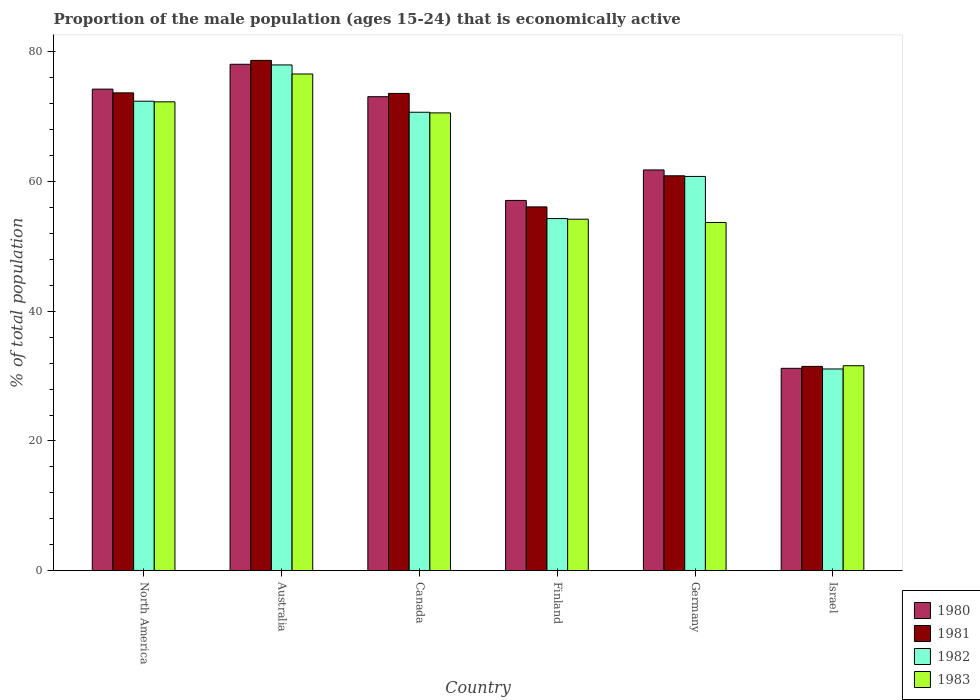How many different coloured bars are there?
Provide a short and direct response. 4. Are the number of bars per tick equal to the number of legend labels?
Make the answer very short. Yes. How many bars are there on the 5th tick from the right?
Your answer should be very brief. 4. What is the proportion of the male population that is economically active in 1980 in Germany?
Make the answer very short. 61.8. Across all countries, what is the maximum proportion of the male population that is economically active in 1983?
Provide a short and direct response. 76.6. Across all countries, what is the minimum proportion of the male population that is economically active in 1980?
Your response must be concise. 31.2. What is the total proportion of the male population that is economically active in 1980 in the graph?
Make the answer very short. 375.57. What is the difference between the proportion of the male population that is economically active in 1983 in Canada and that in North America?
Provide a short and direct response. -1.71. What is the difference between the proportion of the male population that is economically active in 1983 in Israel and the proportion of the male population that is economically active in 1981 in North America?
Your answer should be compact. -42.09. What is the average proportion of the male population that is economically active in 1980 per country?
Make the answer very short. 62.59. What is the difference between the proportion of the male population that is economically active of/in 1982 and proportion of the male population that is economically active of/in 1980 in North America?
Provide a succinct answer. -1.86. What is the ratio of the proportion of the male population that is economically active in 1983 in Canada to that in North America?
Make the answer very short. 0.98. Is the proportion of the male population that is economically active in 1983 in Finland less than that in Israel?
Provide a succinct answer. No. What is the difference between the highest and the second highest proportion of the male population that is economically active in 1983?
Provide a succinct answer. -4.29. What is the difference between the highest and the lowest proportion of the male population that is economically active in 1981?
Give a very brief answer. 47.2. In how many countries, is the proportion of the male population that is economically active in 1981 greater than the average proportion of the male population that is economically active in 1981 taken over all countries?
Your answer should be very brief. 3. Is it the case that in every country, the sum of the proportion of the male population that is economically active in 1982 and proportion of the male population that is economically active in 1981 is greater than the sum of proportion of the male population that is economically active in 1983 and proportion of the male population that is economically active in 1980?
Offer a terse response. No. What does the 1st bar from the left in Australia represents?
Keep it short and to the point. 1980. What does the 3rd bar from the right in Germany represents?
Provide a short and direct response. 1981. How many bars are there?
Make the answer very short. 24. Are all the bars in the graph horizontal?
Your answer should be very brief. No. Does the graph contain any zero values?
Your answer should be very brief. No. Where does the legend appear in the graph?
Give a very brief answer. Bottom right. How many legend labels are there?
Ensure brevity in your answer.  4. What is the title of the graph?
Provide a short and direct response. Proportion of the male population (ages 15-24) that is economically active. Does "1994" appear as one of the legend labels in the graph?
Provide a succinct answer. No. What is the label or title of the Y-axis?
Keep it short and to the point. % of total population. What is the % of total population of 1980 in North America?
Your response must be concise. 74.27. What is the % of total population of 1981 in North America?
Your answer should be compact. 73.69. What is the % of total population in 1982 in North America?
Your answer should be very brief. 72.41. What is the % of total population in 1983 in North America?
Keep it short and to the point. 72.31. What is the % of total population of 1980 in Australia?
Your answer should be very brief. 78.1. What is the % of total population of 1981 in Australia?
Ensure brevity in your answer.  78.7. What is the % of total population in 1982 in Australia?
Ensure brevity in your answer.  78. What is the % of total population of 1983 in Australia?
Your response must be concise. 76.6. What is the % of total population in 1980 in Canada?
Provide a short and direct response. 73.1. What is the % of total population of 1981 in Canada?
Offer a very short reply. 73.6. What is the % of total population in 1982 in Canada?
Offer a very short reply. 70.7. What is the % of total population in 1983 in Canada?
Your response must be concise. 70.6. What is the % of total population in 1980 in Finland?
Keep it short and to the point. 57.1. What is the % of total population in 1981 in Finland?
Make the answer very short. 56.1. What is the % of total population in 1982 in Finland?
Your answer should be very brief. 54.3. What is the % of total population in 1983 in Finland?
Make the answer very short. 54.2. What is the % of total population in 1980 in Germany?
Give a very brief answer. 61.8. What is the % of total population in 1981 in Germany?
Give a very brief answer. 60.9. What is the % of total population of 1982 in Germany?
Your answer should be very brief. 60.8. What is the % of total population in 1983 in Germany?
Give a very brief answer. 53.7. What is the % of total population in 1980 in Israel?
Offer a very short reply. 31.2. What is the % of total population of 1981 in Israel?
Your response must be concise. 31.5. What is the % of total population of 1982 in Israel?
Your response must be concise. 31.1. What is the % of total population in 1983 in Israel?
Give a very brief answer. 31.6. Across all countries, what is the maximum % of total population in 1980?
Your response must be concise. 78.1. Across all countries, what is the maximum % of total population of 1981?
Offer a terse response. 78.7. Across all countries, what is the maximum % of total population in 1983?
Give a very brief answer. 76.6. Across all countries, what is the minimum % of total population in 1980?
Give a very brief answer. 31.2. Across all countries, what is the minimum % of total population in 1981?
Your response must be concise. 31.5. Across all countries, what is the minimum % of total population of 1982?
Provide a short and direct response. 31.1. Across all countries, what is the minimum % of total population of 1983?
Ensure brevity in your answer.  31.6. What is the total % of total population of 1980 in the graph?
Your response must be concise. 375.57. What is the total % of total population of 1981 in the graph?
Your answer should be compact. 374.49. What is the total % of total population in 1982 in the graph?
Keep it short and to the point. 367.31. What is the total % of total population in 1983 in the graph?
Your response must be concise. 359.01. What is the difference between the % of total population in 1980 in North America and that in Australia?
Offer a very short reply. -3.83. What is the difference between the % of total population in 1981 in North America and that in Australia?
Your response must be concise. -5.01. What is the difference between the % of total population of 1982 in North America and that in Australia?
Offer a terse response. -5.59. What is the difference between the % of total population in 1983 in North America and that in Australia?
Make the answer very short. -4.29. What is the difference between the % of total population in 1980 in North America and that in Canada?
Give a very brief answer. 1.17. What is the difference between the % of total population in 1981 in North America and that in Canada?
Ensure brevity in your answer.  0.09. What is the difference between the % of total population of 1982 in North America and that in Canada?
Provide a succinct answer. 1.71. What is the difference between the % of total population of 1983 in North America and that in Canada?
Offer a very short reply. 1.71. What is the difference between the % of total population of 1980 in North America and that in Finland?
Ensure brevity in your answer.  17.17. What is the difference between the % of total population of 1981 in North America and that in Finland?
Your answer should be compact. 17.59. What is the difference between the % of total population in 1982 in North America and that in Finland?
Ensure brevity in your answer.  18.11. What is the difference between the % of total population in 1983 in North America and that in Finland?
Provide a short and direct response. 18.11. What is the difference between the % of total population of 1980 in North America and that in Germany?
Give a very brief answer. 12.47. What is the difference between the % of total population of 1981 in North America and that in Germany?
Offer a very short reply. 12.79. What is the difference between the % of total population in 1982 in North America and that in Germany?
Provide a succinct answer. 11.61. What is the difference between the % of total population of 1983 in North America and that in Germany?
Keep it short and to the point. 18.61. What is the difference between the % of total population in 1980 in North America and that in Israel?
Your answer should be compact. 43.07. What is the difference between the % of total population in 1981 in North America and that in Israel?
Your answer should be compact. 42.19. What is the difference between the % of total population in 1982 in North America and that in Israel?
Offer a terse response. 41.31. What is the difference between the % of total population of 1983 in North America and that in Israel?
Your answer should be very brief. 40.71. What is the difference between the % of total population in 1981 in Australia and that in Canada?
Keep it short and to the point. 5.1. What is the difference between the % of total population in 1982 in Australia and that in Canada?
Offer a very short reply. 7.3. What is the difference between the % of total population of 1981 in Australia and that in Finland?
Your answer should be very brief. 22.6. What is the difference between the % of total population of 1982 in Australia and that in Finland?
Give a very brief answer. 23.7. What is the difference between the % of total population in 1983 in Australia and that in Finland?
Keep it short and to the point. 22.4. What is the difference between the % of total population of 1980 in Australia and that in Germany?
Give a very brief answer. 16.3. What is the difference between the % of total population of 1982 in Australia and that in Germany?
Your answer should be compact. 17.2. What is the difference between the % of total population in 1983 in Australia and that in Germany?
Offer a very short reply. 22.9. What is the difference between the % of total population in 1980 in Australia and that in Israel?
Offer a terse response. 46.9. What is the difference between the % of total population in 1981 in Australia and that in Israel?
Offer a terse response. 47.2. What is the difference between the % of total population of 1982 in Australia and that in Israel?
Offer a terse response. 46.9. What is the difference between the % of total population in 1980 in Canada and that in Finland?
Offer a terse response. 16. What is the difference between the % of total population in 1982 in Canada and that in Finland?
Your answer should be compact. 16.4. What is the difference between the % of total population of 1980 in Canada and that in Germany?
Keep it short and to the point. 11.3. What is the difference between the % of total population in 1982 in Canada and that in Germany?
Offer a very short reply. 9.9. What is the difference between the % of total population in 1980 in Canada and that in Israel?
Make the answer very short. 41.9. What is the difference between the % of total population in 1981 in Canada and that in Israel?
Your answer should be compact. 42.1. What is the difference between the % of total population in 1982 in Canada and that in Israel?
Make the answer very short. 39.6. What is the difference between the % of total population in 1982 in Finland and that in Germany?
Offer a very short reply. -6.5. What is the difference between the % of total population in 1980 in Finland and that in Israel?
Keep it short and to the point. 25.9. What is the difference between the % of total population in 1981 in Finland and that in Israel?
Your response must be concise. 24.6. What is the difference between the % of total population in 1982 in Finland and that in Israel?
Your answer should be very brief. 23.2. What is the difference between the % of total population of 1983 in Finland and that in Israel?
Your response must be concise. 22.6. What is the difference between the % of total population in 1980 in Germany and that in Israel?
Provide a short and direct response. 30.6. What is the difference between the % of total population of 1981 in Germany and that in Israel?
Offer a terse response. 29.4. What is the difference between the % of total population in 1982 in Germany and that in Israel?
Provide a short and direct response. 29.7. What is the difference between the % of total population of 1983 in Germany and that in Israel?
Provide a succinct answer. 22.1. What is the difference between the % of total population of 1980 in North America and the % of total population of 1981 in Australia?
Your answer should be compact. -4.43. What is the difference between the % of total population of 1980 in North America and the % of total population of 1982 in Australia?
Your response must be concise. -3.73. What is the difference between the % of total population of 1980 in North America and the % of total population of 1983 in Australia?
Make the answer very short. -2.33. What is the difference between the % of total population of 1981 in North America and the % of total population of 1982 in Australia?
Make the answer very short. -4.31. What is the difference between the % of total population in 1981 in North America and the % of total population in 1983 in Australia?
Keep it short and to the point. -2.91. What is the difference between the % of total population in 1982 in North America and the % of total population in 1983 in Australia?
Provide a succinct answer. -4.19. What is the difference between the % of total population of 1980 in North America and the % of total population of 1981 in Canada?
Give a very brief answer. 0.67. What is the difference between the % of total population in 1980 in North America and the % of total population in 1982 in Canada?
Your response must be concise. 3.57. What is the difference between the % of total population of 1980 in North America and the % of total population of 1983 in Canada?
Your response must be concise. 3.67. What is the difference between the % of total population in 1981 in North America and the % of total population in 1982 in Canada?
Ensure brevity in your answer.  2.99. What is the difference between the % of total population of 1981 in North America and the % of total population of 1983 in Canada?
Your answer should be very brief. 3.09. What is the difference between the % of total population of 1982 in North America and the % of total population of 1983 in Canada?
Give a very brief answer. 1.81. What is the difference between the % of total population of 1980 in North America and the % of total population of 1981 in Finland?
Your answer should be very brief. 18.17. What is the difference between the % of total population in 1980 in North America and the % of total population in 1982 in Finland?
Your answer should be compact. 19.97. What is the difference between the % of total population in 1980 in North America and the % of total population in 1983 in Finland?
Make the answer very short. 20.07. What is the difference between the % of total population in 1981 in North America and the % of total population in 1982 in Finland?
Your response must be concise. 19.39. What is the difference between the % of total population in 1981 in North America and the % of total population in 1983 in Finland?
Provide a short and direct response. 19.49. What is the difference between the % of total population in 1982 in North America and the % of total population in 1983 in Finland?
Your answer should be compact. 18.21. What is the difference between the % of total population of 1980 in North America and the % of total population of 1981 in Germany?
Provide a short and direct response. 13.37. What is the difference between the % of total population of 1980 in North America and the % of total population of 1982 in Germany?
Your answer should be very brief. 13.47. What is the difference between the % of total population in 1980 in North America and the % of total population in 1983 in Germany?
Your response must be concise. 20.57. What is the difference between the % of total population of 1981 in North America and the % of total population of 1982 in Germany?
Your answer should be compact. 12.89. What is the difference between the % of total population in 1981 in North America and the % of total population in 1983 in Germany?
Make the answer very short. 19.99. What is the difference between the % of total population of 1982 in North America and the % of total population of 1983 in Germany?
Offer a terse response. 18.71. What is the difference between the % of total population of 1980 in North America and the % of total population of 1981 in Israel?
Your response must be concise. 42.77. What is the difference between the % of total population in 1980 in North America and the % of total population in 1982 in Israel?
Make the answer very short. 43.17. What is the difference between the % of total population in 1980 in North America and the % of total population in 1983 in Israel?
Your answer should be very brief. 42.67. What is the difference between the % of total population of 1981 in North America and the % of total population of 1982 in Israel?
Offer a terse response. 42.59. What is the difference between the % of total population of 1981 in North America and the % of total population of 1983 in Israel?
Offer a terse response. 42.09. What is the difference between the % of total population in 1982 in North America and the % of total population in 1983 in Israel?
Provide a succinct answer. 40.81. What is the difference between the % of total population of 1980 in Australia and the % of total population of 1982 in Canada?
Provide a succinct answer. 7.4. What is the difference between the % of total population in 1981 in Australia and the % of total population in 1982 in Canada?
Your response must be concise. 8. What is the difference between the % of total population of 1981 in Australia and the % of total population of 1983 in Canada?
Offer a very short reply. 8.1. What is the difference between the % of total population of 1980 in Australia and the % of total population of 1981 in Finland?
Make the answer very short. 22. What is the difference between the % of total population of 1980 in Australia and the % of total population of 1982 in Finland?
Your answer should be very brief. 23.8. What is the difference between the % of total population of 1980 in Australia and the % of total population of 1983 in Finland?
Keep it short and to the point. 23.9. What is the difference between the % of total population in 1981 in Australia and the % of total population in 1982 in Finland?
Your answer should be compact. 24.4. What is the difference between the % of total population in 1981 in Australia and the % of total population in 1983 in Finland?
Your response must be concise. 24.5. What is the difference between the % of total population in 1982 in Australia and the % of total population in 1983 in Finland?
Give a very brief answer. 23.8. What is the difference between the % of total population in 1980 in Australia and the % of total population in 1983 in Germany?
Offer a very short reply. 24.4. What is the difference between the % of total population of 1981 in Australia and the % of total population of 1982 in Germany?
Your answer should be very brief. 17.9. What is the difference between the % of total population of 1982 in Australia and the % of total population of 1983 in Germany?
Your answer should be very brief. 24.3. What is the difference between the % of total population of 1980 in Australia and the % of total population of 1981 in Israel?
Your answer should be very brief. 46.6. What is the difference between the % of total population in 1980 in Australia and the % of total population in 1983 in Israel?
Provide a succinct answer. 46.5. What is the difference between the % of total population in 1981 in Australia and the % of total population in 1982 in Israel?
Make the answer very short. 47.6. What is the difference between the % of total population of 1981 in Australia and the % of total population of 1983 in Israel?
Provide a short and direct response. 47.1. What is the difference between the % of total population of 1982 in Australia and the % of total population of 1983 in Israel?
Your answer should be compact. 46.4. What is the difference between the % of total population of 1980 in Canada and the % of total population of 1983 in Finland?
Provide a succinct answer. 18.9. What is the difference between the % of total population in 1981 in Canada and the % of total population in 1982 in Finland?
Keep it short and to the point. 19.3. What is the difference between the % of total population in 1981 in Canada and the % of total population in 1983 in Finland?
Ensure brevity in your answer.  19.4. What is the difference between the % of total population of 1980 in Canada and the % of total population of 1982 in Germany?
Provide a succinct answer. 12.3. What is the difference between the % of total population of 1981 in Canada and the % of total population of 1982 in Germany?
Offer a very short reply. 12.8. What is the difference between the % of total population in 1980 in Canada and the % of total population in 1981 in Israel?
Offer a terse response. 41.6. What is the difference between the % of total population of 1980 in Canada and the % of total population of 1983 in Israel?
Offer a terse response. 41.5. What is the difference between the % of total population of 1981 in Canada and the % of total population of 1982 in Israel?
Make the answer very short. 42.5. What is the difference between the % of total population in 1982 in Canada and the % of total population in 1983 in Israel?
Provide a succinct answer. 39.1. What is the difference between the % of total population in 1980 in Finland and the % of total population in 1982 in Germany?
Make the answer very short. -3.7. What is the difference between the % of total population of 1981 in Finland and the % of total population of 1982 in Germany?
Provide a short and direct response. -4.7. What is the difference between the % of total population in 1982 in Finland and the % of total population in 1983 in Germany?
Your response must be concise. 0.6. What is the difference between the % of total population of 1980 in Finland and the % of total population of 1981 in Israel?
Make the answer very short. 25.6. What is the difference between the % of total population of 1980 in Finland and the % of total population of 1982 in Israel?
Give a very brief answer. 26. What is the difference between the % of total population of 1981 in Finland and the % of total population of 1982 in Israel?
Provide a short and direct response. 25. What is the difference between the % of total population of 1982 in Finland and the % of total population of 1983 in Israel?
Provide a short and direct response. 22.7. What is the difference between the % of total population of 1980 in Germany and the % of total population of 1981 in Israel?
Make the answer very short. 30.3. What is the difference between the % of total population in 1980 in Germany and the % of total population in 1982 in Israel?
Keep it short and to the point. 30.7. What is the difference between the % of total population of 1980 in Germany and the % of total population of 1983 in Israel?
Your answer should be very brief. 30.2. What is the difference between the % of total population of 1981 in Germany and the % of total population of 1982 in Israel?
Make the answer very short. 29.8. What is the difference between the % of total population in 1981 in Germany and the % of total population in 1983 in Israel?
Ensure brevity in your answer.  29.3. What is the difference between the % of total population of 1982 in Germany and the % of total population of 1983 in Israel?
Offer a very short reply. 29.2. What is the average % of total population of 1980 per country?
Provide a succinct answer. 62.59. What is the average % of total population of 1981 per country?
Offer a very short reply. 62.41. What is the average % of total population of 1982 per country?
Offer a terse response. 61.22. What is the average % of total population in 1983 per country?
Make the answer very short. 59.83. What is the difference between the % of total population of 1980 and % of total population of 1981 in North America?
Provide a short and direct response. 0.58. What is the difference between the % of total population of 1980 and % of total population of 1982 in North America?
Your answer should be compact. 1.86. What is the difference between the % of total population in 1980 and % of total population in 1983 in North America?
Keep it short and to the point. 1.96. What is the difference between the % of total population in 1981 and % of total population in 1982 in North America?
Your response must be concise. 1.28. What is the difference between the % of total population in 1981 and % of total population in 1983 in North America?
Give a very brief answer. 1.38. What is the difference between the % of total population in 1982 and % of total population in 1983 in North America?
Provide a short and direct response. 0.1. What is the difference between the % of total population of 1980 and % of total population of 1981 in Australia?
Provide a short and direct response. -0.6. What is the difference between the % of total population of 1981 and % of total population of 1982 in Australia?
Offer a terse response. 0.7. What is the difference between the % of total population of 1982 and % of total population of 1983 in Australia?
Ensure brevity in your answer.  1.4. What is the difference between the % of total population in 1980 and % of total population in 1982 in Canada?
Your response must be concise. 2.4. What is the difference between the % of total population of 1980 and % of total population of 1983 in Canada?
Offer a terse response. 2.5. What is the difference between the % of total population in 1980 and % of total population in 1981 in Finland?
Your answer should be compact. 1. What is the difference between the % of total population in 1980 and % of total population in 1982 in Finland?
Offer a terse response. 2.8. What is the difference between the % of total population of 1980 and % of total population of 1983 in Finland?
Provide a short and direct response. 2.9. What is the difference between the % of total population in 1981 and % of total population in 1983 in Finland?
Give a very brief answer. 1.9. What is the difference between the % of total population of 1980 and % of total population of 1982 in Germany?
Offer a very short reply. 1. What is the difference between the % of total population in 1980 and % of total population in 1983 in Germany?
Provide a succinct answer. 8.1. What is the difference between the % of total population of 1981 and % of total population of 1982 in Germany?
Your response must be concise. 0.1. What is the difference between the % of total population of 1981 and % of total population of 1983 in Germany?
Ensure brevity in your answer.  7.2. What is the difference between the % of total population in 1982 and % of total population in 1983 in Germany?
Your response must be concise. 7.1. What is the difference between the % of total population in 1980 and % of total population in 1983 in Israel?
Give a very brief answer. -0.4. What is the difference between the % of total population in 1981 and % of total population in 1983 in Israel?
Provide a short and direct response. -0.1. What is the difference between the % of total population of 1982 and % of total population of 1983 in Israel?
Make the answer very short. -0.5. What is the ratio of the % of total population in 1980 in North America to that in Australia?
Provide a succinct answer. 0.95. What is the ratio of the % of total population in 1981 in North America to that in Australia?
Your response must be concise. 0.94. What is the ratio of the % of total population of 1982 in North America to that in Australia?
Keep it short and to the point. 0.93. What is the ratio of the % of total population in 1983 in North America to that in Australia?
Offer a very short reply. 0.94. What is the ratio of the % of total population of 1980 in North America to that in Canada?
Provide a short and direct response. 1.02. What is the ratio of the % of total population of 1981 in North America to that in Canada?
Provide a short and direct response. 1. What is the ratio of the % of total population of 1982 in North America to that in Canada?
Provide a succinct answer. 1.02. What is the ratio of the % of total population of 1983 in North America to that in Canada?
Ensure brevity in your answer.  1.02. What is the ratio of the % of total population in 1980 in North America to that in Finland?
Keep it short and to the point. 1.3. What is the ratio of the % of total population of 1981 in North America to that in Finland?
Offer a very short reply. 1.31. What is the ratio of the % of total population of 1982 in North America to that in Finland?
Your answer should be compact. 1.33. What is the ratio of the % of total population of 1983 in North America to that in Finland?
Make the answer very short. 1.33. What is the ratio of the % of total population in 1980 in North America to that in Germany?
Offer a very short reply. 1.2. What is the ratio of the % of total population of 1981 in North America to that in Germany?
Make the answer very short. 1.21. What is the ratio of the % of total population of 1982 in North America to that in Germany?
Ensure brevity in your answer.  1.19. What is the ratio of the % of total population in 1983 in North America to that in Germany?
Provide a succinct answer. 1.35. What is the ratio of the % of total population in 1980 in North America to that in Israel?
Offer a terse response. 2.38. What is the ratio of the % of total population in 1981 in North America to that in Israel?
Your answer should be very brief. 2.34. What is the ratio of the % of total population in 1982 in North America to that in Israel?
Offer a very short reply. 2.33. What is the ratio of the % of total population of 1983 in North America to that in Israel?
Your response must be concise. 2.29. What is the ratio of the % of total population of 1980 in Australia to that in Canada?
Offer a terse response. 1.07. What is the ratio of the % of total population of 1981 in Australia to that in Canada?
Provide a succinct answer. 1.07. What is the ratio of the % of total population in 1982 in Australia to that in Canada?
Provide a succinct answer. 1.1. What is the ratio of the % of total population in 1983 in Australia to that in Canada?
Offer a very short reply. 1.08. What is the ratio of the % of total population of 1980 in Australia to that in Finland?
Provide a succinct answer. 1.37. What is the ratio of the % of total population in 1981 in Australia to that in Finland?
Provide a succinct answer. 1.4. What is the ratio of the % of total population in 1982 in Australia to that in Finland?
Your answer should be very brief. 1.44. What is the ratio of the % of total population of 1983 in Australia to that in Finland?
Offer a terse response. 1.41. What is the ratio of the % of total population in 1980 in Australia to that in Germany?
Give a very brief answer. 1.26. What is the ratio of the % of total population of 1981 in Australia to that in Germany?
Ensure brevity in your answer.  1.29. What is the ratio of the % of total population in 1982 in Australia to that in Germany?
Keep it short and to the point. 1.28. What is the ratio of the % of total population in 1983 in Australia to that in Germany?
Give a very brief answer. 1.43. What is the ratio of the % of total population of 1980 in Australia to that in Israel?
Give a very brief answer. 2.5. What is the ratio of the % of total population in 1981 in Australia to that in Israel?
Provide a short and direct response. 2.5. What is the ratio of the % of total population of 1982 in Australia to that in Israel?
Offer a very short reply. 2.51. What is the ratio of the % of total population of 1983 in Australia to that in Israel?
Ensure brevity in your answer.  2.42. What is the ratio of the % of total population in 1980 in Canada to that in Finland?
Give a very brief answer. 1.28. What is the ratio of the % of total population in 1981 in Canada to that in Finland?
Provide a succinct answer. 1.31. What is the ratio of the % of total population of 1982 in Canada to that in Finland?
Offer a very short reply. 1.3. What is the ratio of the % of total population of 1983 in Canada to that in Finland?
Your answer should be compact. 1.3. What is the ratio of the % of total population in 1980 in Canada to that in Germany?
Offer a terse response. 1.18. What is the ratio of the % of total population of 1981 in Canada to that in Germany?
Your response must be concise. 1.21. What is the ratio of the % of total population of 1982 in Canada to that in Germany?
Provide a short and direct response. 1.16. What is the ratio of the % of total population in 1983 in Canada to that in Germany?
Your answer should be compact. 1.31. What is the ratio of the % of total population in 1980 in Canada to that in Israel?
Give a very brief answer. 2.34. What is the ratio of the % of total population in 1981 in Canada to that in Israel?
Provide a short and direct response. 2.34. What is the ratio of the % of total population in 1982 in Canada to that in Israel?
Ensure brevity in your answer.  2.27. What is the ratio of the % of total population of 1983 in Canada to that in Israel?
Offer a very short reply. 2.23. What is the ratio of the % of total population of 1980 in Finland to that in Germany?
Offer a very short reply. 0.92. What is the ratio of the % of total population of 1981 in Finland to that in Germany?
Provide a succinct answer. 0.92. What is the ratio of the % of total population in 1982 in Finland to that in Germany?
Ensure brevity in your answer.  0.89. What is the ratio of the % of total population of 1983 in Finland to that in Germany?
Keep it short and to the point. 1.01. What is the ratio of the % of total population in 1980 in Finland to that in Israel?
Make the answer very short. 1.83. What is the ratio of the % of total population of 1981 in Finland to that in Israel?
Make the answer very short. 1.78. What is the ratio of the % of total population in 1982 in Finland to that in Israel?
Offer a very short reply. 1.75. What is the ratio of the % of total population of 1983 in Finland to that in Israel?
Your answer should be very brief. 1.72. What is the ratio of the % of total population of 1980 in Germany to that in Israel?
Your answer should be compact. 1.98. What is the ratio of the % of total population in 1981 in Germany to that in Israel?
Give a very brief answer. 1.93. What is the ratio of the % of total population of 1982 in Germany to that in Israel?
Make the answer very short. 1.96. What is the ratio of the % of total population of 1983 in Germany to that in Israel?
Make the answer very short. 1.7. What is the difference between the highest and the second highest % of total population of 1980?
Provide a short and direct response. 3.83. What is the difference between the highest and the second highest % of total population in 1981?
Provide a succinct answer. 5.01. What is the difference between the highest and the second highest % of total population of 1982?
Your answer should be compact. 5.59. What is the difference between the highest and the second highest % of total population of 1983?
Your answer should be very brief. 4.29. What is the difference between the highest and the lowest % of total population in 1980?
Your response must be concise. 46.9. What is the difference between the highest and the lowest % of total population in 1981?
Make the answer very short. 47.2. What is the difference between the highest and the lowest % of total population in 1982?
Your answer should be compact. 46.9. 